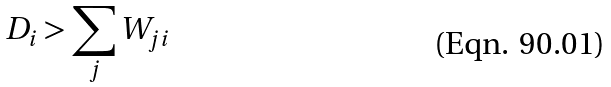<formula> <loc_0><loc_0><loc_500><loc_500>D _ { i } > \sum _ { j } W _ { j i }</formula> 